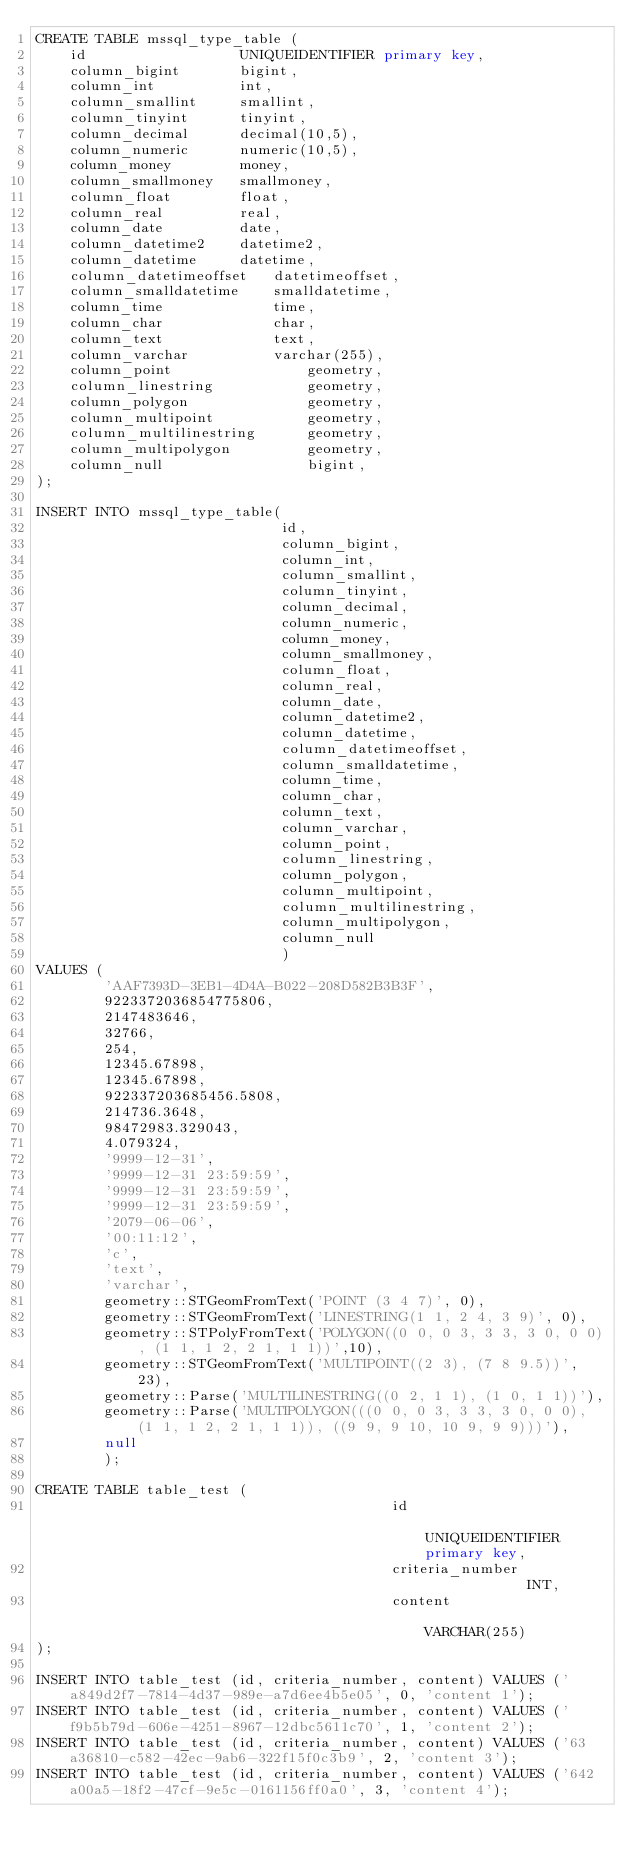<code> <loc_0><loc_0><loc_500><loc_500><_SQL_>CREATE TABLE mssql_type_table (
    id                  UNIQUEIDENTIFIER primary key,
    column_bigint       bigint,
    column_int          int,
    column_smallint     smallint,
    column_tinyint      tinyint,
    column_decimal      decimal(10,5),
    column_numeric      numeric(10,5),
    column_money        money,
    column_smallmoney   smallmoney,
    column_float        float,
    column_real         real,
    column_date         date,
    column_datetime2    datetime2,
    column_datetime     datetime,
    column_datetimeoffset   datetimeoffset,
    column_smalldatetime    smalldatetime,
    column_time             time,
    column_char             char,
    column_text             text,
    column_varchar          varchar(255),
    column_point                geometry,
    column_linestring           geometry,
    column_polygon              geometry,
    column_multipoint           geometry,
    column_multilinestring      geometry,
    column_multipolygon         geometry,
    column_null                 bigint,
);

INSERT INTO mssql_type_table(
                             id,
                             column_bigint,
                             column_int,
                             column_smallint,
                             column_tinyint,
                             column_decimal,
                             column_numeric,
                             column_money,
                             column_smallmoney,
                             column_float,
                             column_real,
                             column_date,
                             column_datetime2,
                             column_datetime,
                             column_datetimeoffset,
                             column_smalldatetime,
                             column_time,
                             column_char,
                             column_text,
                             column_varchar,
                             column_point,
                             column_linestring,
                             column_polygon,
                             column_multipoint,
                             column_multilinestring,
                             column_multipolygon,
                             column_null
                             )
VALUES (
        'AAF7393D-3EB1-4D4A-B022-208D582B3B3F',
        9223372036854775806,
        2147483646,
        32766,
        254,
        12345.67898,
        12345.67898,
        922337203685456.5808,
        214736.3648,
        98472983.329043,
        4.079324,
        '9999-12-31',
        '9999-12-31 23:59:59',
        '9999-12-31 23:59:59',
        '9999-12-31 23:59:59',
        '2079-06-06',
        '00:11:12',
        'c',
        'text',
        'varchar',
        geometry::STGeomFromText('POINT (3 4 7)', 0),
        geometry::STGeomFromText('LINESTRING(1 1, 2 4, 3 9)', 0),
        geometry::STPolyFromText('POLYGON((0 0, 0 3, 3 3, 3 0, 0 0), (1 1, 1 2, 2 1, 1 1))',10),
        geometry::STGeomFromText('MULTIPOINT((2 3), (7 8 9.5))', 23),
        geometry::Parse('MULTILINESTRING((0 2, 1 1), (1 0, 1 1))'),
        geometry::Parse('MULTIPOLYGON(((0 0, 0 3, 3 3, 3 0, 0 0), (1 1, 1 2, 2 1, 1 1)), ((9 9, 9 10, 10 9, 9 9)))'),
        null
        );

CREATE TABLE table_test (
                                          id                          UNIQUEIDENTIFIER primary key,
                                          criteria_number             INT,
                                          content                     VARCHAR(255)
);

INSERT INTO table_test (id, criteria_number, content) VALUES ('a849d2f7-7814-4d37-989e-a7d6ee4b5e05', 0, 'content 1');
INSERT INTO table_test (id, criteria_number, content) VALUES ('f9b5b79d-606e-4251-8967-12dbc5611c70', 1, 'content 2');
INSERT INTO table_test (id, criteria_number, content) VALUES ('63a36810-c582-42ec-9ab6-322f15f0c3b9', 2, 'content 3');
INSERT INTO table_test (id, criteria_number, content) VALUES ('642a00a5-18f2-47cf-9e5c-0161156ff0a0', 3, 'content 4');</code> 